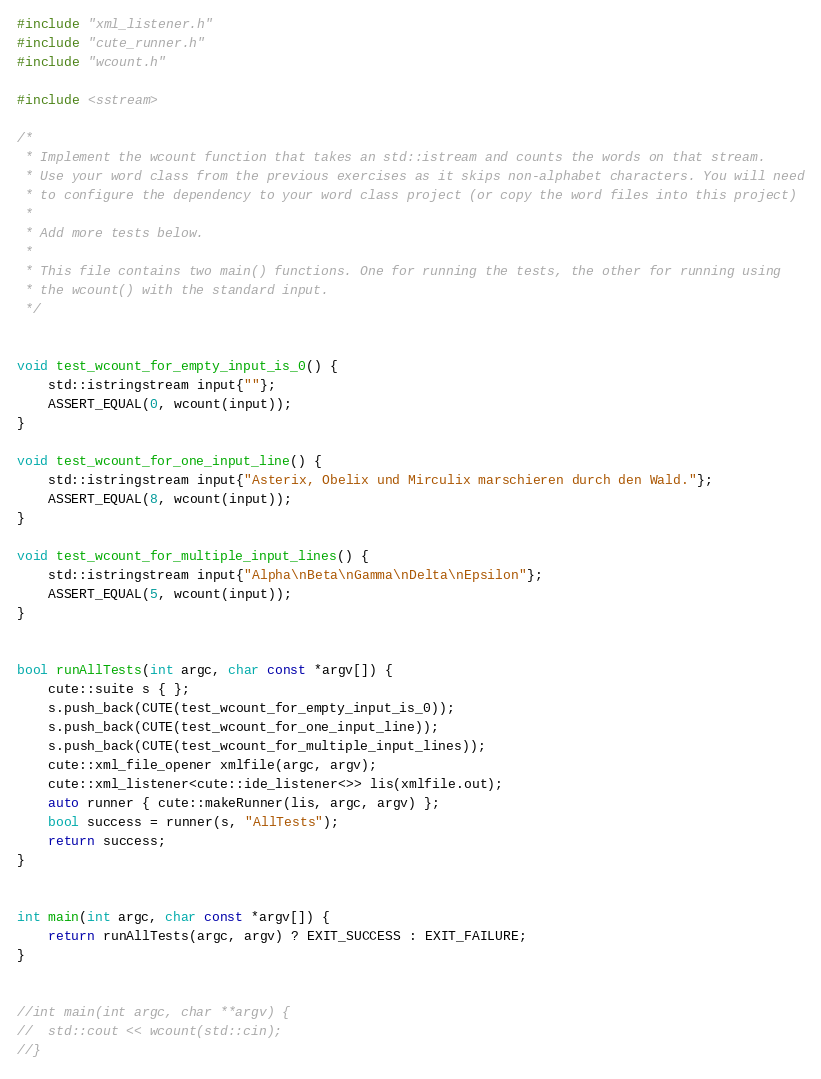Convert code to text. <code><loc_0><loc_0><loc_500><loc_500><_C++_>#include "xml_listener.h"
#include "cute_runner.h"
#include "wcount.h"

#include <sstream>

/*
 * Implement the wcount function that takes an std::istream and counts the words on that stream.
 * Use your word class from the previous exercises as it skips non-alphabet characters. You will need
 * to configure the dependency to your word class project (or copy the word files into this project)
 *
 * Add more tests below.
 *
 * This file contains two main() functions. One for running the tests, the other for running using
 * the wcount() with the standard input.
 */


void test_wcount_for_empty_input_is_0() {
	std::istringstream input{""};
	ASSERT_EQUAL(0, wcount(input));
}

void test_wcount_for_one_input_line() {
	std::istringstream input{"Asterix, Obelix und Mirculix marschieren durch den Wald."};
	ASSERT_EQUAL(8, wcount(input));
}

void test_wcount_for_multiple_input_lines() {
	std::istringstream input{"Alpha\nBeta\nGamma\nDelta\nEpsilon"};
	ASSERT_EQUAL(5, wcount(input));
}


bool runAllTests(int argc, char const *argv[]) {
	cute::suite s { };
	s.push_back(CUTE(test_wcount_for_empty_input_is_0));
	s.push_back(CUTE(test_wcount_for_one_input_line));
	s.push_back(CUTE(test_wcount_for_multiple_input_lines));
	cute::xml_file_opener xmlfile(argc, argv);
	cute::xml_listener<cute::ide_listener<>> lis(xmlfile.out);
	auto runner { cute::makeRunner(lis, argc, argv) };
	bool success = runner(s, "AllTests");
	return success;
}


int main(int argc, char const *argv[]) {
    return runAllTests(argc, argv) ? EXIT_SUCCESS : EXIT_FAILURE;
}


//int main(int argc, char **argv) {
//	std::cout << wcount(std::cin);
//}
</code> 